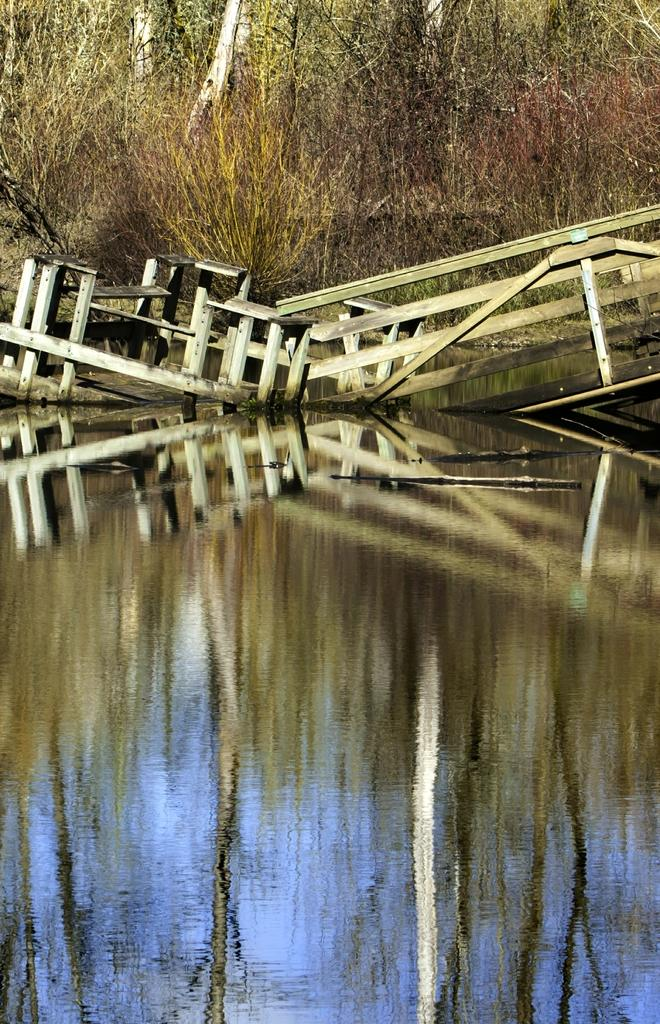What is in the water in the image? There is a wooden railing in the water. What type of vegetation can be seen in the image? There are dried plants visible in the image. What can be seen in the background of the image? There are trees in the background of the image. Where is the library located in the image? There is no library present in the image. What type of shoe can be seen on the dried plants in the image? There are no shoes visible in the image; it only features a wooden railing, dried plants, and trees in the background. 